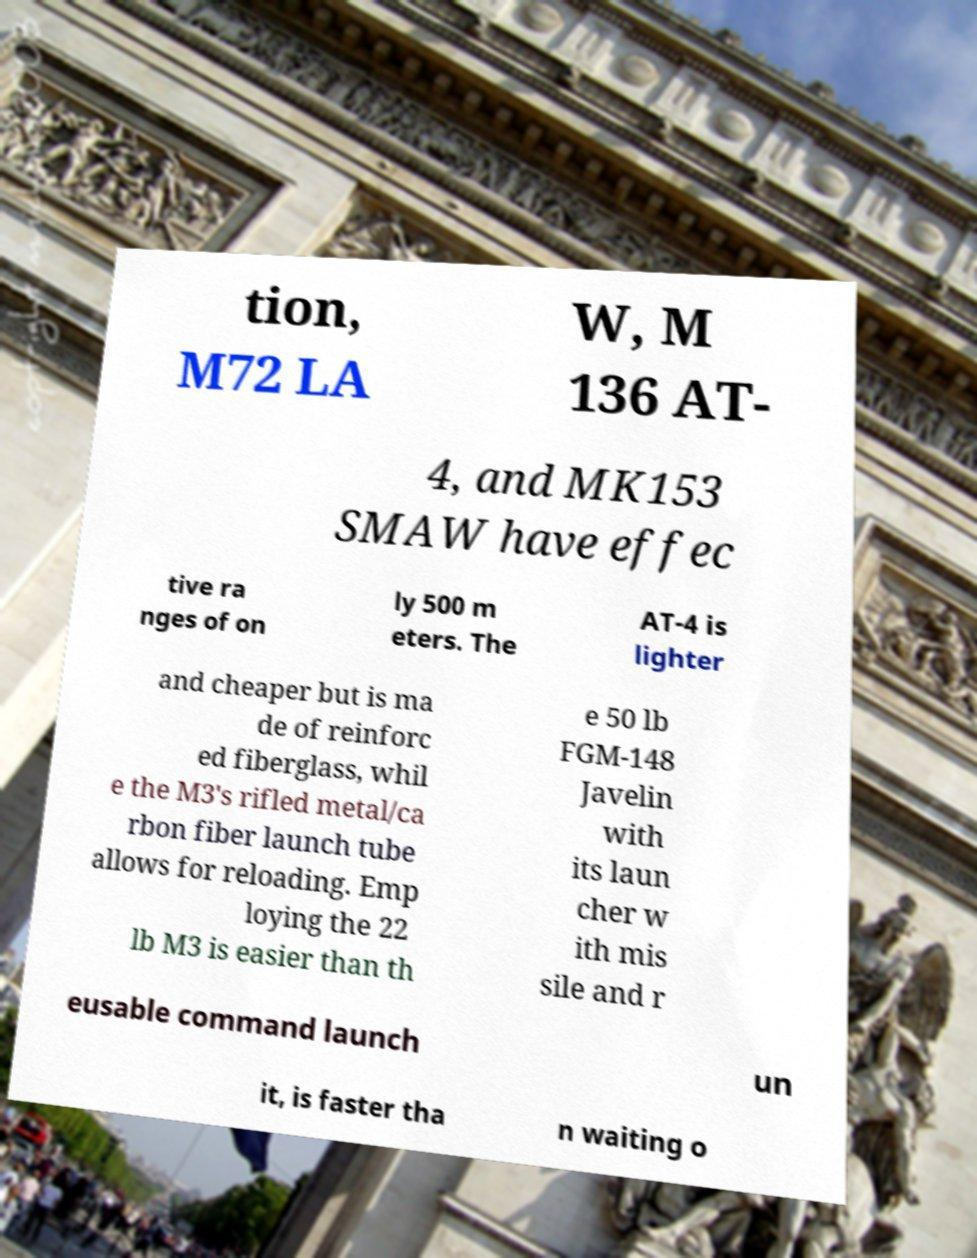For documentation purposes, I need the text within this image transcribed. Could you provide that? tion, M72 LA W, M 136 AT- 4, and MK153 SMAW have effec tive ra nges of on ly 500 m eters. The AT-4 is lighter and cheaper but is ma de of reinforc ed fiberglass, whil e the M3's rifled metal/ca rbon fiber launch tube allows for reloading. Emp loying the 22 lb M3 is easier than th e 50 lb FGM-148 Javelin with its laun cher w ith mis sile and r eusable command launch un it, is faster tha n waiting o 